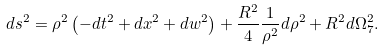<formula> <loc_0><loc_0><loc_500><loc_500>d s ^ { 2 } = \rho ^ { 2 } \left ( - d t ^ { 2 } + d x ^ { 2 } + d w ^ { 2 } \right ) + \frac { R ^ { 2 } } { 4 } \frac { 1 } { \rho ^ { 2 } } d \rho ^ { 2 } + R ^ { 2 } d \Omega _ { 7 } ^ { 2 } .</formula> 